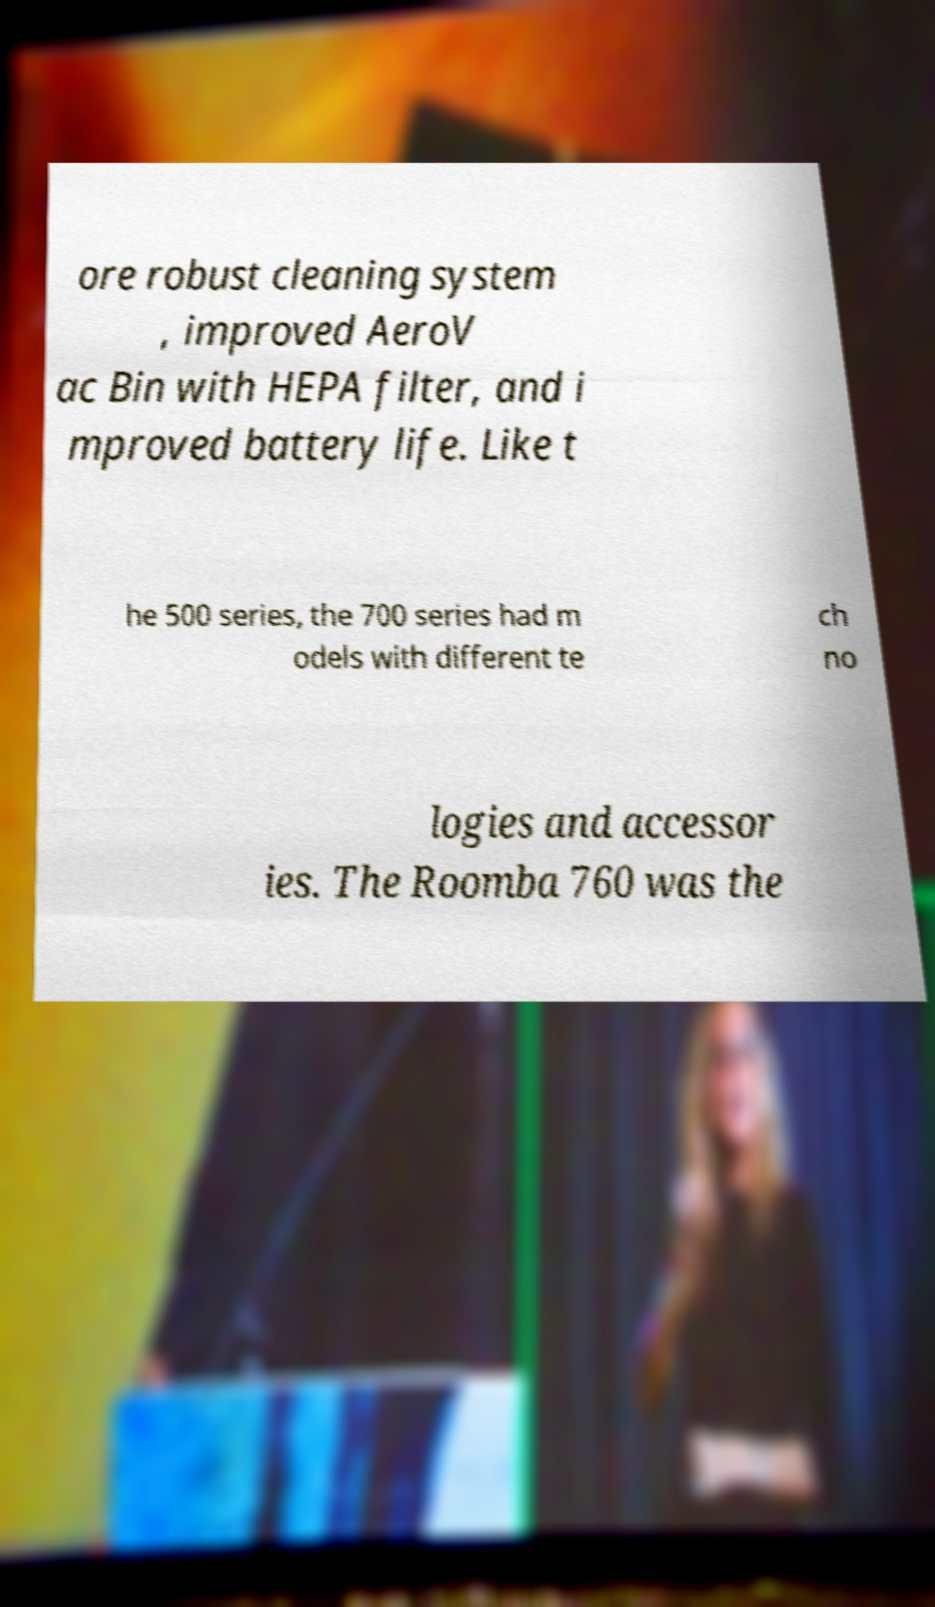Could you extract and type out the text from this image? ore robust cleaning system , improved AeroV ac Bin with HEPA filter, and i mproved battery life. Like t he 500 series, the 700 series had m odels with different te ch no logies and accessor ies. The Roomba 760 was the 